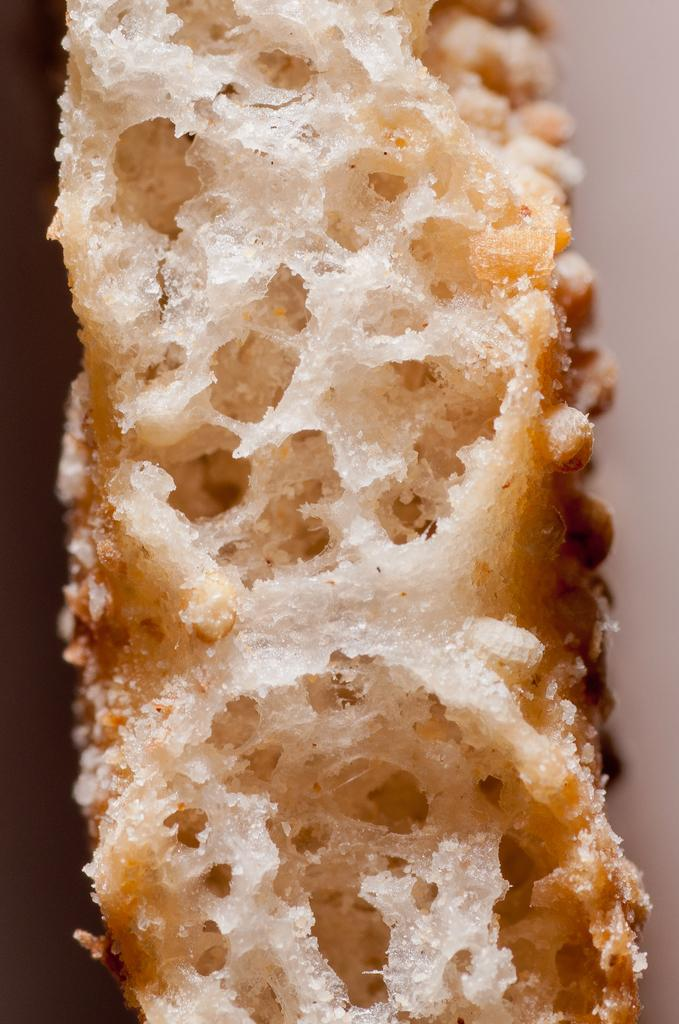What can be seen in the image? There is a food item in the image. Where is the receipt for the food item in the image? There is no receipt present in the image; only the food item is visible. What type of pail is used to serve the food item in the image? There is no pail present in the image; the food item is not served in a pail. 